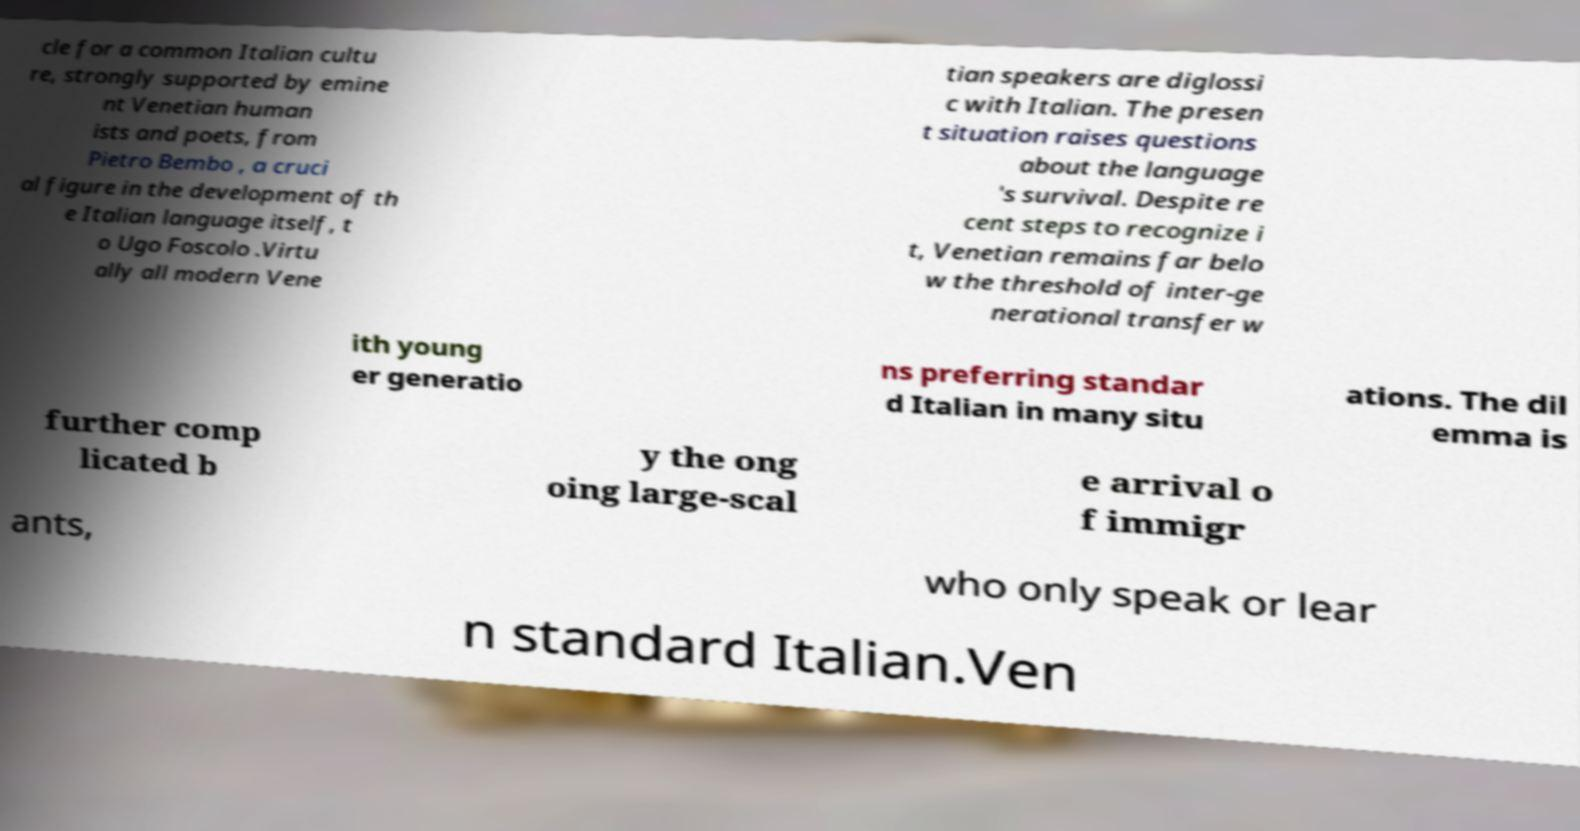For documentation purposes, I need the text within this image transcribed. Could you provide that? cle for a common Italian cultu re, strongly supported by emine nt Venetian human ists and poets, from Pietro Bembo , a cruci al figure in the development of th e Italian language itself, t o Ugo Foscolo .Virtu ally all modern Vene tian speakers are diglossi c with Italian. The presen t situation raises questions about the language 's survival. Despite re cent steps to recognize i t, Venetian remains far belo w the threshold of inter-ge nerational transfer w ith young er generatio ns preferring standar d Italian in many situ ations. The dil emma is further comp licated b y the ong oing large-scal e arrival o f immigr ants, who only speak or lear n standard Italian.Ven 